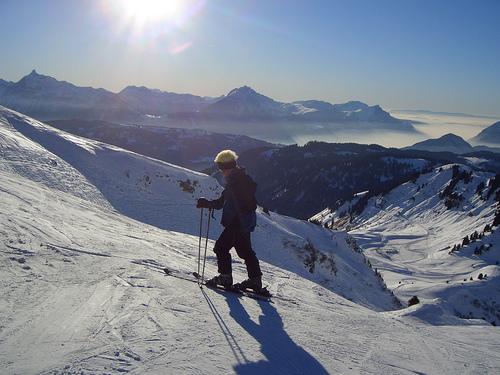Are they skiing down the mountain?
Write a very short answer. No. How many ski poles does this person have?
Give a very brief answer. 2. What color is the snowboarder's jacket?
Concise answer only. Black. Is the person on the ground?
Short answer required. Yes. Is all of the ground covered in snow?
Write a very short answer. Yes. 